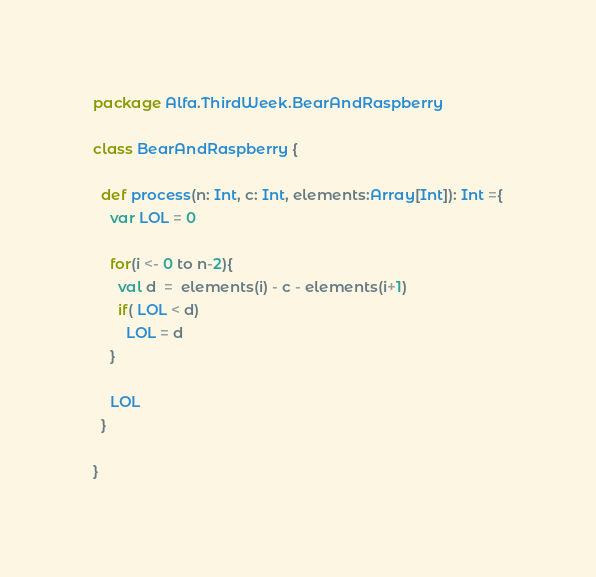Convert code to text. <code><loc_0><loc_0><loc_500><loc_500><_Scala_>package Alfa.ThirdWeek.BearAndRaspberry

class BearAndRaspberry {

  def process(n: Int, c: Int, elements:Array[Int]): Int ={
    var LOL = 0

    for(i <- 0 to n-2){
      val d  =  elements(i) - c - elements(i+1)
      if( LOL < d)
        LOL = d
    }

    LOL
  }

}
</code> 